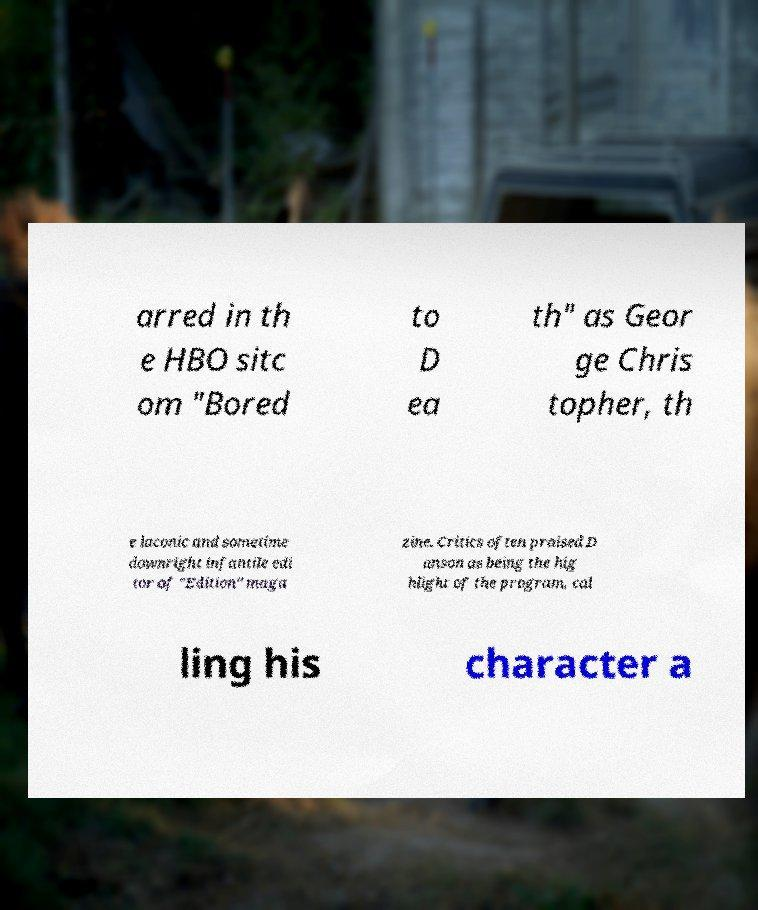For documentation purposes, I need the text within this image transcribed. Could you provide that? arred in th e HBO sitc om "Bored to D ea th" as Geor ge Chris topher, th e laconic and sometime downright infantile edi tor of "Edition" maga zine. Critics often praised D anson as being the hig hlight of the program, cal ling his character a 